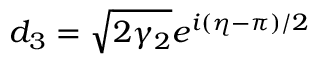<formula> <loc_0><loc_0><loc_500><loc_500>d _ { 3 } = \sqrt { 2 \gamma _ { 2 } } e ^ { i ( \eta - \pi ) / 2 }</formula> 